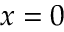<formula> <loc_0><loc_0><loc_500><loc_500>x = 0</formula> 